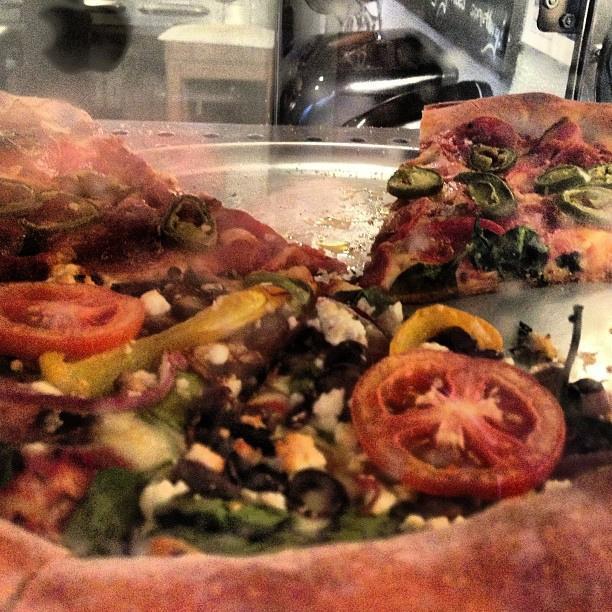How many people are on a horse?
Give a very brief answer. 0. 